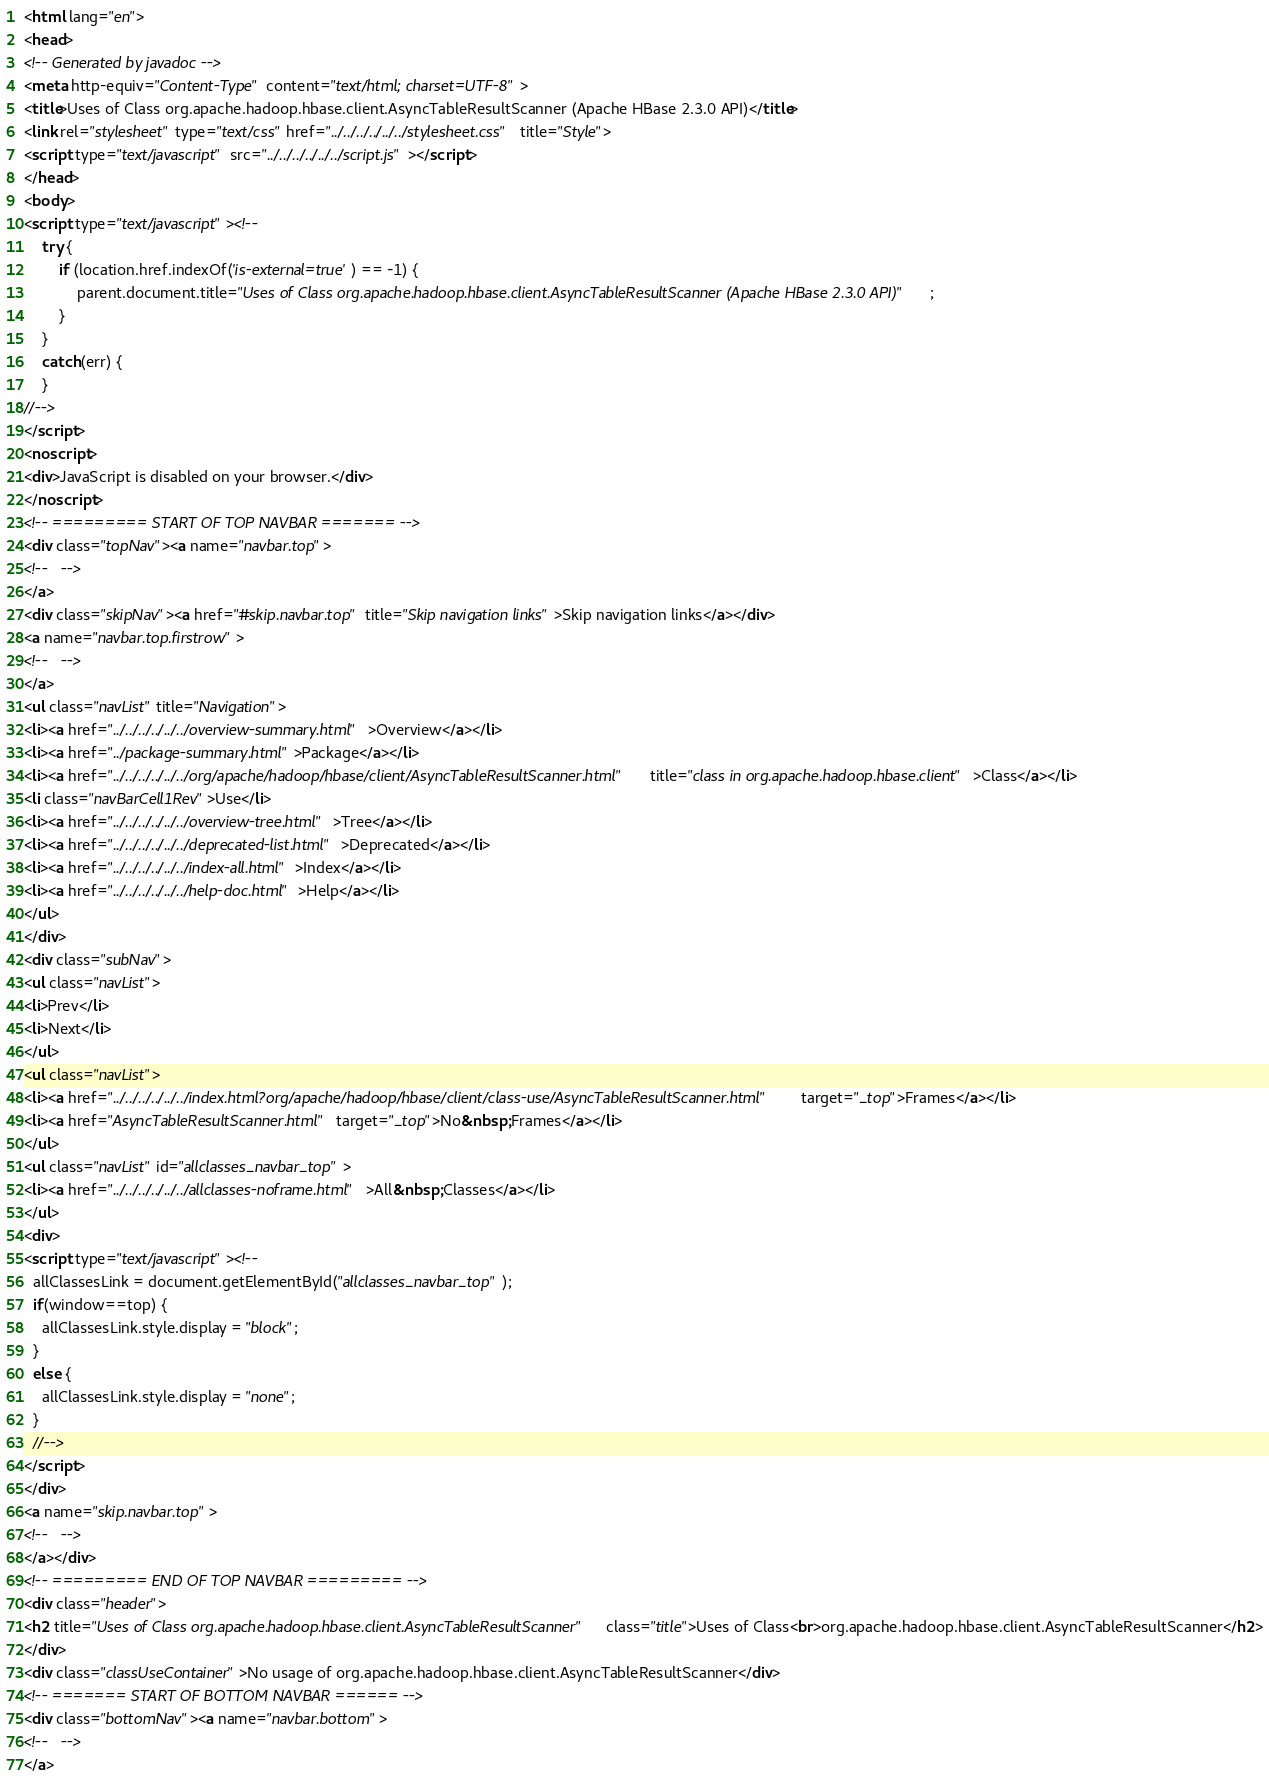Convert code to text. <code><loc_0><loc_0><loc_500><loc_500><_HTML_><html lang="en">
<head>
<!-- Generated by javadoc -->
<meta http-equiv="Content-Type" content="text/html; charset=UTF-8">
<title>Uses of Class org.apache.hadoop.hbase.client.AsyncTableResultScanner (Apache HBase 2.3.0 API)</title>
<link rel="stylesheet" type="text/css" href="../../../../../../stylesheet.css" title="Style">
<script type="text/javascript" src="../../../../../../script.js"></script>
</head>
<body>
<script type="text/javascript"><!--
    try {
        if (location.href.indexOf('is-external=true') == -1) {
            parent.document.title="Uses of Class org.apache.hadoop.hbase.client.AsyncTableResultScanner (Apache HBase 2.3.0 API)";
        }
    }
    catch(err) {
    }
//-->
</script>
<noscript>
<div>JavaScript is disabled on your browser.</div>
</noscript>
<!-- ========= START OF TOP NAVBAR ======= -->
<div class="topNav"><a name="navbar.top">
<!--   -->
</a>
<div class="skipNav"><a href="#skip.navbar.top" title="Skip navigation links">Skip navigation links</a></div>
<a name="navbar.top.firstrow">
<!--   -->
</a>
<ul class="navList" title="Navigation">
<li><a href="../../../../../../overview-summary.html">Overview</a></li>
<li><a href="../package-summary.html">Package</a></li>
<li><a href="../../../../../../org/apache/hadoop/hbase/client/AsyncTableResultScanner.html" title="class in org.apache.hadoop.hbase.client">Class</a></li>
<li class="navBarCell1Rev">Use</li>
<li><a href="../../../../../../overview-tree.html">Tree</a></li>
<li><a href="../../../../../../deprecated-list.html">Deprecated</a></li>
<li><a href="../../../../../../index-all.html">Index</a></li>
<li><a href="../../../../../../help-doc.html">Help</a></li>
</ul>
</div>
<div class="subNav">
<ul class="navList">
<li>Prev</li>
<li>Next</li>
</ul>
<ul class="navList">
<li><a href="../../../../../../index.html?org/apache/hadoop/hbase/client/class-use/AsyncTableResultScanner.html" target="_top">Frames</a></li>
<li><a href="AsyncTableResultScanner.html" target="_top">No&nbsp;Frames</a></li>
</ul>
<ul class="navList" id="allclasses_navbar_top">
<li><a href="../../../../../../allclasses-noframe.html">All&nbsp;Classes</a></li>
</ul>
<div>
<script type="text/javascript"><!--
  allClassesLink = document.getElementById("allclasses_navbar_top");
  if(window==top) {
    allClassesLink.style.display = "block";
  }
  else {
    allClassesLink.style.display = "none";
  }
  //-->
</script>
</div>
<a name="skip.navbar.top">
<!--   -->
</a></div>
<!-- ========= END OF TOP NAVBAR ========= -->
<div class="header">
<h2 title="Uses of Class org.apache.hadoop.hbase.client.AsyncTableResultScanner" class="title">Uses of Class<br>org.apache.hadoop.hbase.client.AsyncTableResultScanner</h2>
</div>
<div class="classUseContainer">No usage of org.apache.hadoop.hbase.client.AsyncTableResultScanner</div>
<!-- ======= START OF BOTTOM NAVBAR ====== -->
<div class="bottomNav"><a name="navbar.bottom">
<!--   -->
</a></code> 